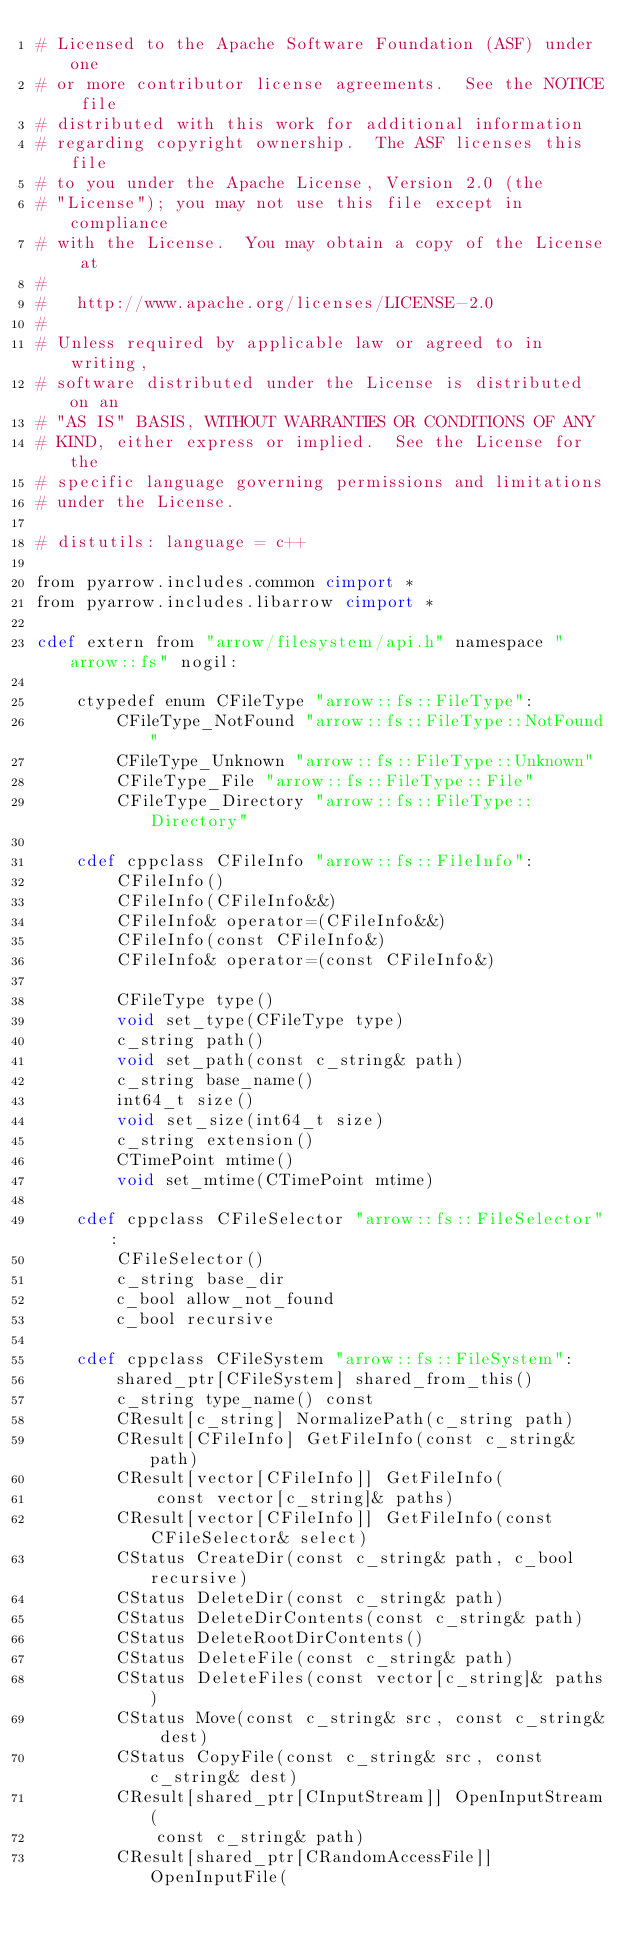Convert code to text. <code><loc_0><loc_0><loc_500><loc_500><_Cython_># Licensed to the Apache Software Foundation (ASF) under one
# or more contributor license agreements.  See the NOTICE file
# distributed with this work for additional information
# regarding copyright ownership.  The ASF licenses this file
# to you under the Apache License, Version 2.0 (the
# "License"); you may not use this file except in compliance
# with the License.  You may obtain a copy of the License at
#
#   http://www.apache.org/licenses/LICENSE-2.0
#
# Unless required by applicable law or agreed to in writing,
# software distributed under the License is distributed on an
# "AS IS" BASIS, WITHOUT WARRANTIES OR CONDITIONS OF ANY
# KIND, either express or implied.  See the License for the
# specific language governing permissions and limitations
# under the License.

# distutils: language = c++

from pyarrow.includes.common cimport *
from pyarrow.includes.libarrow cimport *

cdef extern from "arrow/filesystem/api.h" namespace "arrow::fs" nogil:

    ctypedef enum CFileType "arrow::fs::FileType":
        CFileType_NotFound "arrow::fs::FileType::NotFound"
        CFileType_Unknown "arrow::fs::FileType::Unknown"
        CFileType_File "arrow::fs::FileType::File"
        CFileType_Directory "arrow::fs::FileType::Directory"

    cdef cppclass CFileInfo "arrow::fs::FileInfo":
        CFileInfo()
        CFileInfo(CFileInfo&&)
        CFileInfo& operator=(CFileInfo&&)
        CFileInfo(const CFileInfo&)
        CFileInfo& operator=(const CFileInfo&)

        CFileType type()
        void set_type(CFileType type)
        c_string path()
        void set_path(const c_string& path)
        c_string base_name()
        int64_t size()
        void set_size(int64_t size)
        c_string extension()
        CTimePoint mtime()
        void set_mtime(CTimePoint mtime)

    cdef cppclass CFileSelector "arrow::fs::FileSelector":
        CFileSelector()
        c_string base_dir
        c_bool allow_not_found
        c_bool recursive

    cdef cppclass CFileSystem "arrow::fs::FileSystem":
        shared_ptr[CFileSystem] shared_from_this()
        c_string type_name() const
        CResult[c_string] NormalizePath(c_string path)
        CResult[CFileInfo] GetFileInfo(const c_string& path)
        CResult[vector[CFileInfo]] GetFileInfo(
            const vector[c_string]& paths)
        CResult[vector[CFileInfo]] GetFileInfo(const CFileSelector& select)
        CStatus CreateDir(const c_string& path, c_bool recursive)
        CStatus DeleteDir(const c_string& path)
        CStatus DeleteDirContents(const c_string& path)
        CStatus DeleteRootDirContents()
        CStatus DeleteFile(const c_string& path)
        CStatus DeleteFiles(const vector[c_string]& paths)
        CStatus Move(const c_string& src, const c_string& dest)
        CStatus CopyFile(const c_string& src, const c_string& dest)
        CResult[shared_ptr[CInputStream]] OpenInputStream(
            const c_string& path)
        CResult[shared_ptr[CRandomAccessFile]] OpenInputFile(</code> 